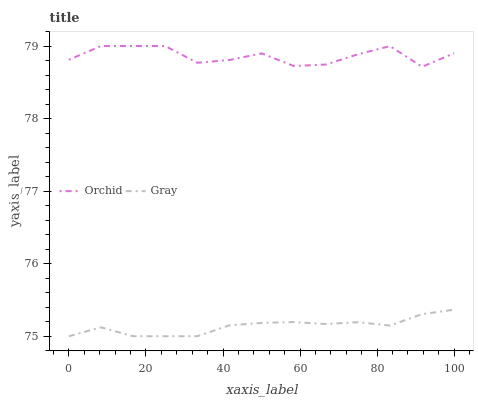Does Gray have the minimum area under the curve?
Answer yes or no. Yes. Does Orchid have the maximum area under the curve?
Answer yes or no. Yes. Does Orchid have the minimum area under the curve?
Answer yes or no. No. Is Gray the smoothest?
Answer yes or no. Yes. Is Orchid the roughest?
Answer yes or no. Yes. Is Orchid the smoothest?
Answer yes or no. No. Does Gray have the lowest value?
Answer yes or no. Yes. Does Orchid have the lowest value?
Answer yes or no. No. Does Orchid have the highest value?
Answer yes or no. Yes. Is Gray less than Orchid?
Answer yes or no. Yes. Is Orchid greater than Gray?
Answer yes or no. Yes. Does Gray intersect Orchid?
Answer yes or no. No. 